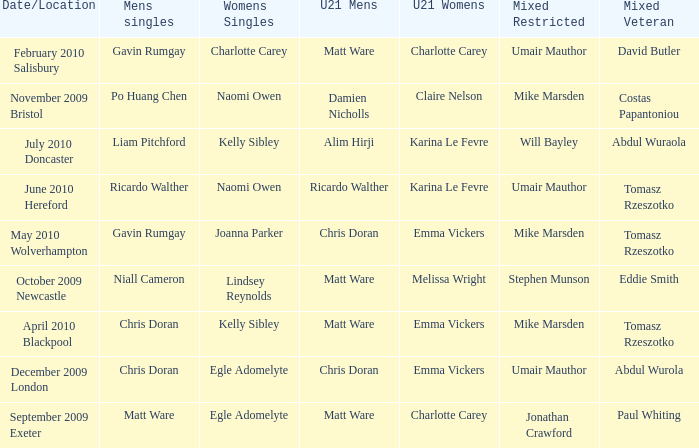When Paul Whiting won the mixed veteran, who won the mixed restricted? Jonathan Crawford. 